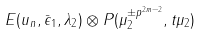<formula> <loc_0><loc_0><loc_500><loc_500>E ( u _ { n } , \bar { \epsilon } _ { 1 } , \lambda _ { 2 } ) \otimes P ( \mu _ { 2 } ^ { \pm p ^ { 2 m - 2 } } , t \mu _ { 2 } )</formula> 